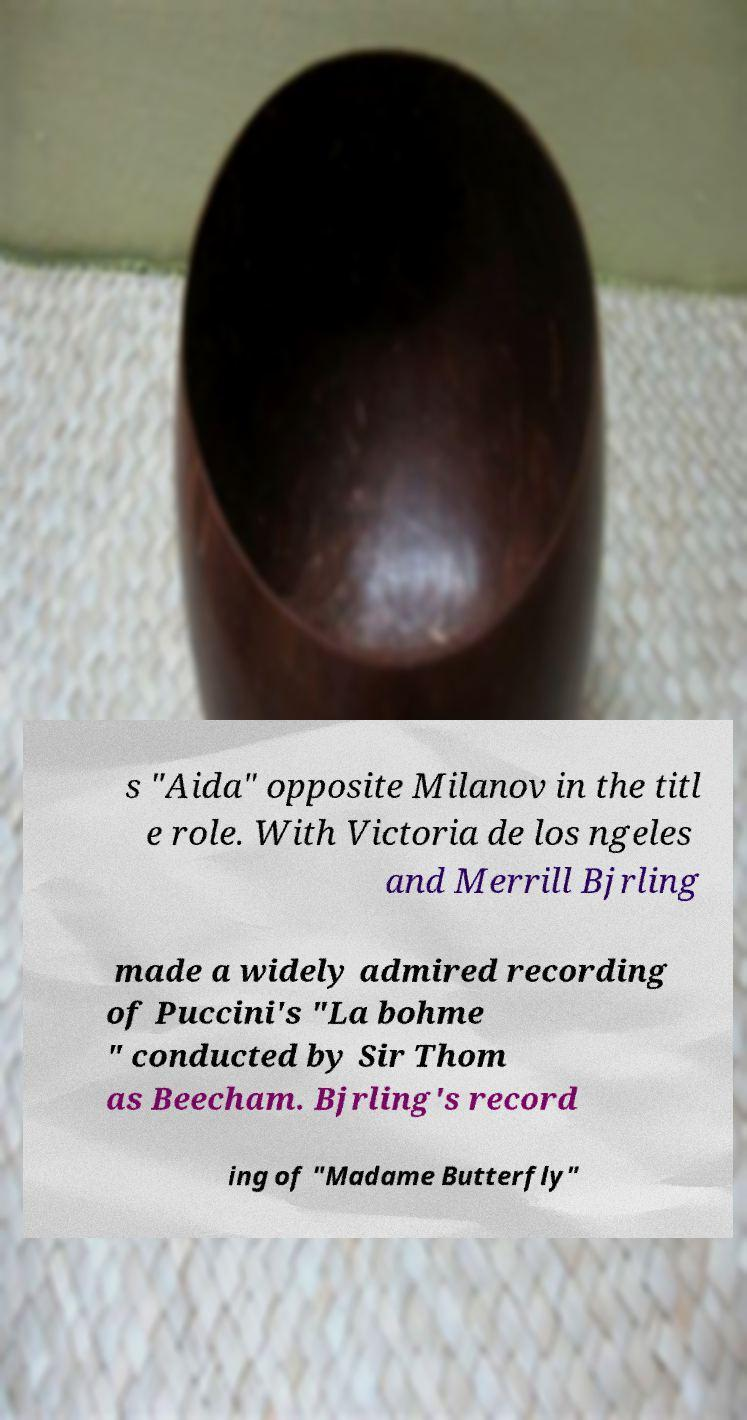I need the written content from this picture converted into text. Can you do that? s "Aida" opposite Milanov in the titl e role. With Victoria de los ngeles and Merrill Bjrling made a widely admired recording of Puccini's "La bohme " conducted by Sir Thom as Beecham. Bjrling's record ing of "Madame Butterfly" 